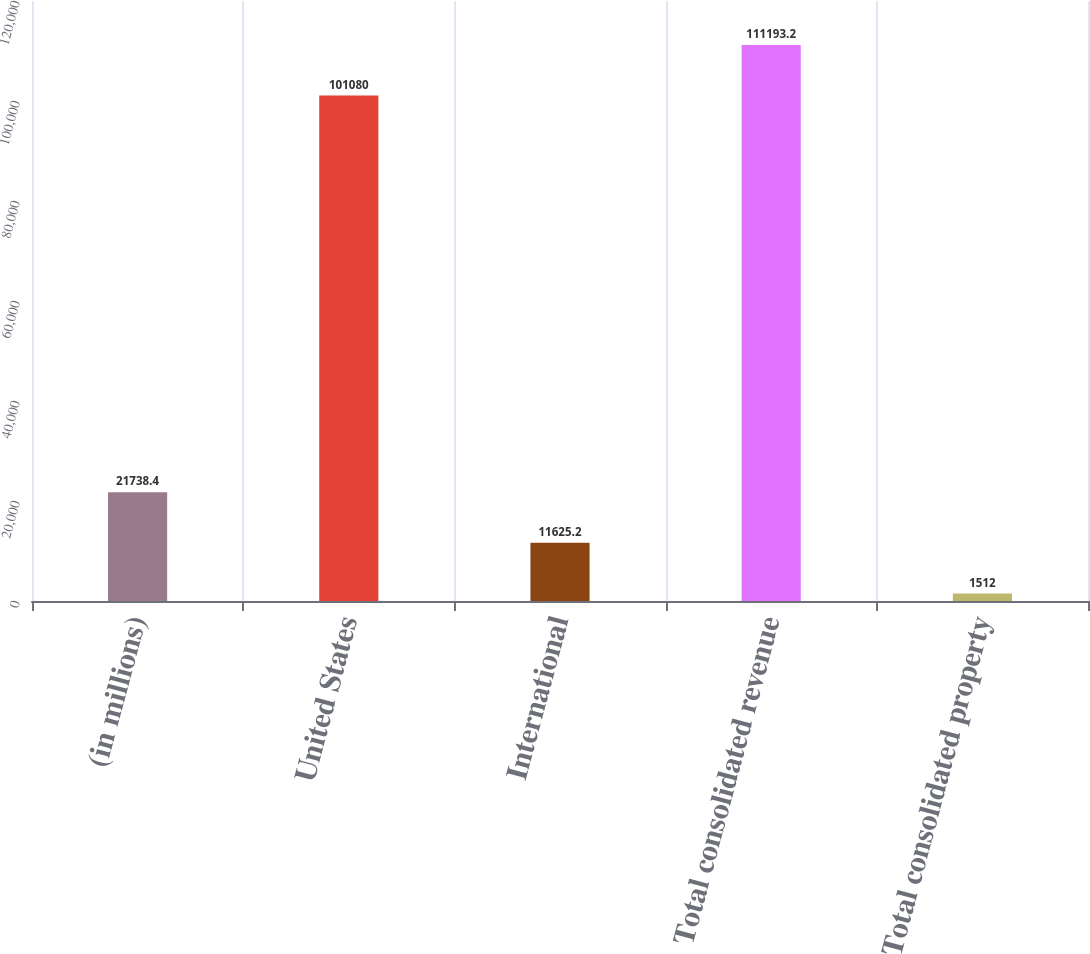<chart> <loc_0><loc_0><loc_500><loc_500><bar_chart><fcel>(in millions)<fcel>United States<fcel>International<fcel>Total consolidated revenue<fcel>Total consolidated property<nl><fcel>21738.4<fcel>101080<fcel>11625.2<fcel>111193<fcel>1512<nl></chart> 